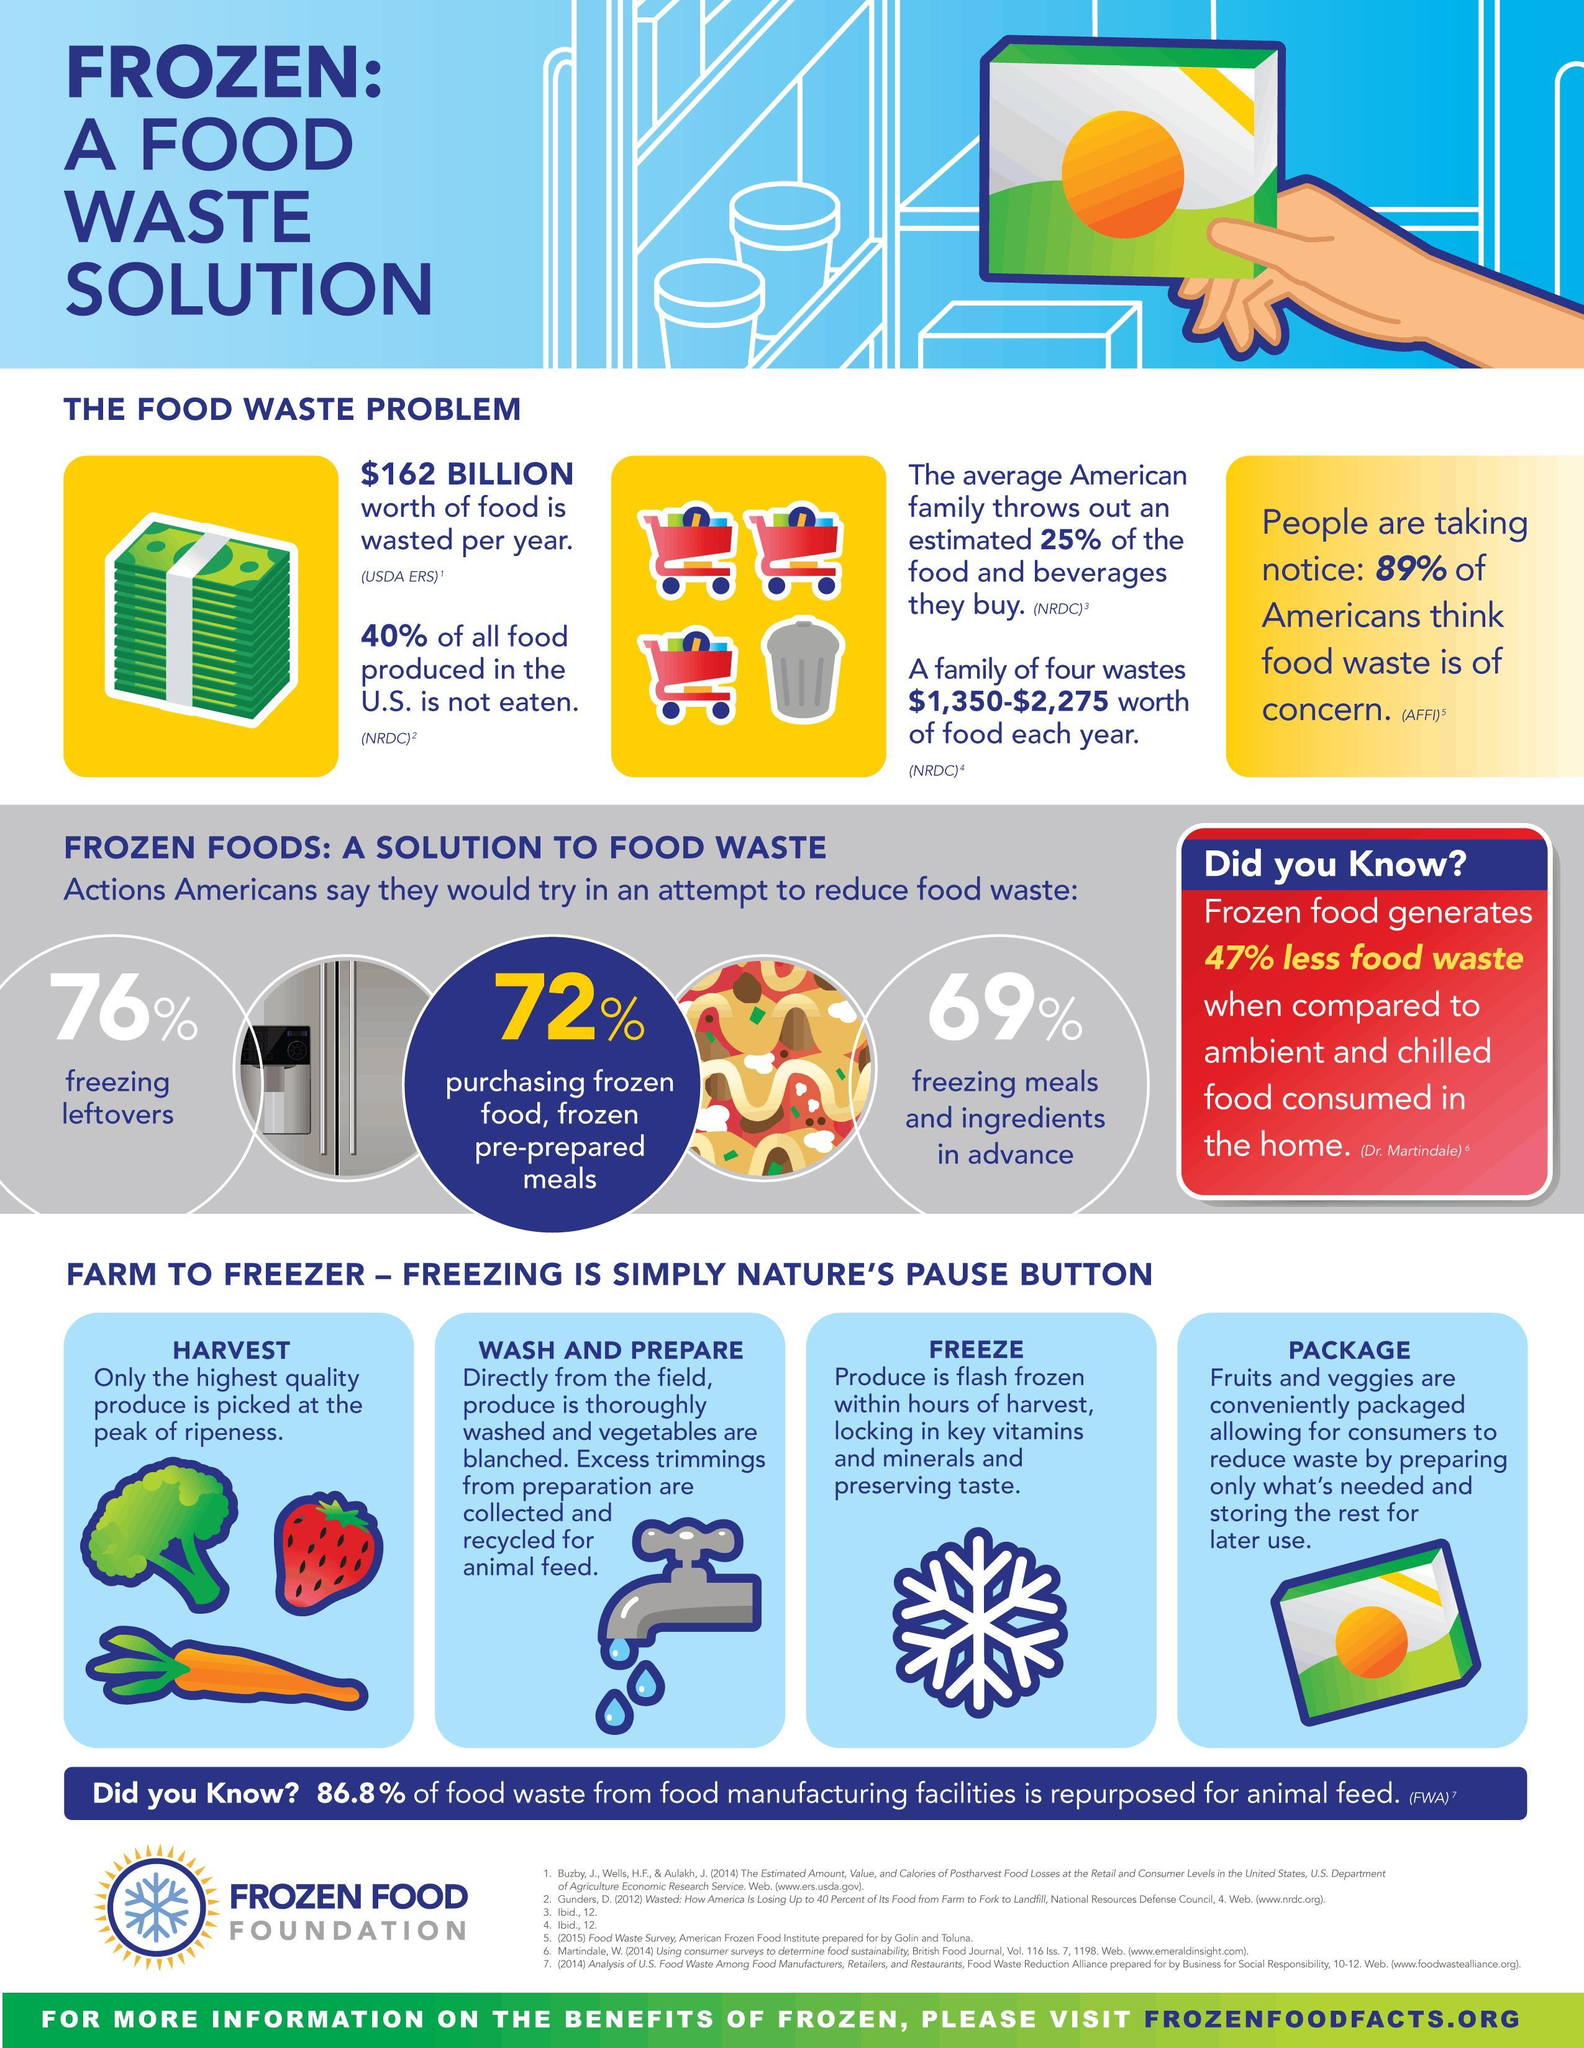what are the steps in the process of food production before packaging?
Answer the question with a short phrase. harvest, wash and prepare, freeze What percent of American people think food waste is not a concern? 11 what is the procedure after wash and prepare in the process of food production? freeze what is the procedure after freeze in the process of food production? package What percent of Americans are not buying frozen food or frozen pre-prepared meals? 28% what are the steps in the process of food production before freezing? harvest, wash and prepare what are the steps in the process of food production after harvesting? wash and prepare, freeze, package what percent of all food produced in the US is eaten? 60 what is the procedure before wash and prepare in the process of food production? harvest what is the procedure after harvest in the process of food production? wash and prepare 